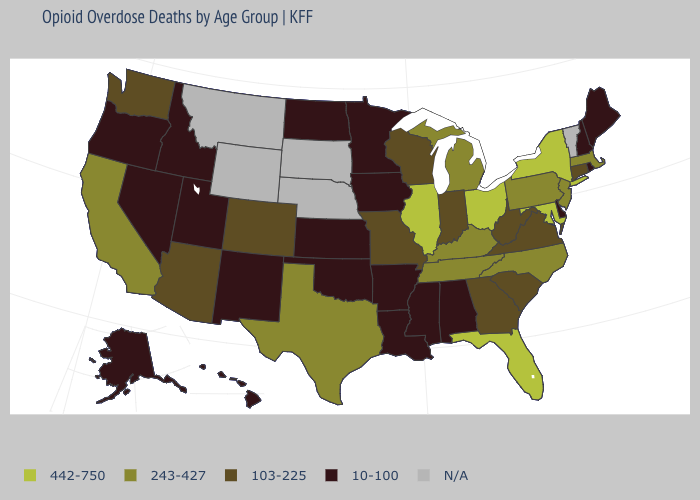Name the states that have a value in the range N/A?
Write a very short answer. Montana, Nebraska, South Dakota, Vermont, Wyoming. Name the states that have a value in the range N/A?
Keep it brief. Montana, Nebraska, South Dakota, Vermont, Wyoming. Name the states that have a value in the range 10-100?
Concise answer only. Alabama, Alaska, Arkansas, Delaware, Hawaii, Idaho, Iowa, Kansas, Louisiana, Maine, Minnesota, Mississippi, Nevada, New Hampshire, New Mexico, North Dakota, Oklahoma, Oregon, Rhode Island, Utah. Is the legend a continuous bar?
Give a very brief answer. No. What is the value of Wyoming?
Short answer required. N/A. Name the states that have a value in the range N/A?
Be succinct. Montana, Nebraska, South Dakota, Vermont, Wyoming. What is the value of Nevada?
Short answer required. 10-100. Which states hav the highest value in the West?
Keep it brief. California. Name the states that have a value in the range 103-225?
Short answer required. Arizona, Colorado, Connecticut, Georgia, Indiana, Missouri, South Carolina, Virginia, Washington, West Virginia, Wisconsin. Which states have the lowest value in the MidWest?
Short answer required. Iowa, Kansas, Minnesota, North Dakota. Among the states that border New Jersey , does Pennsylvania have the highest value?
Short answer required. No. How many symbols are there in the legend?
Give a very brief answer. 5. Name the states that have a value in the range N/A?
Concise answer only. Montana, Nebraska, South Dakota, Vermont, Wyoming. What is the value of Idaho?
Concise answer only. 10-100. 